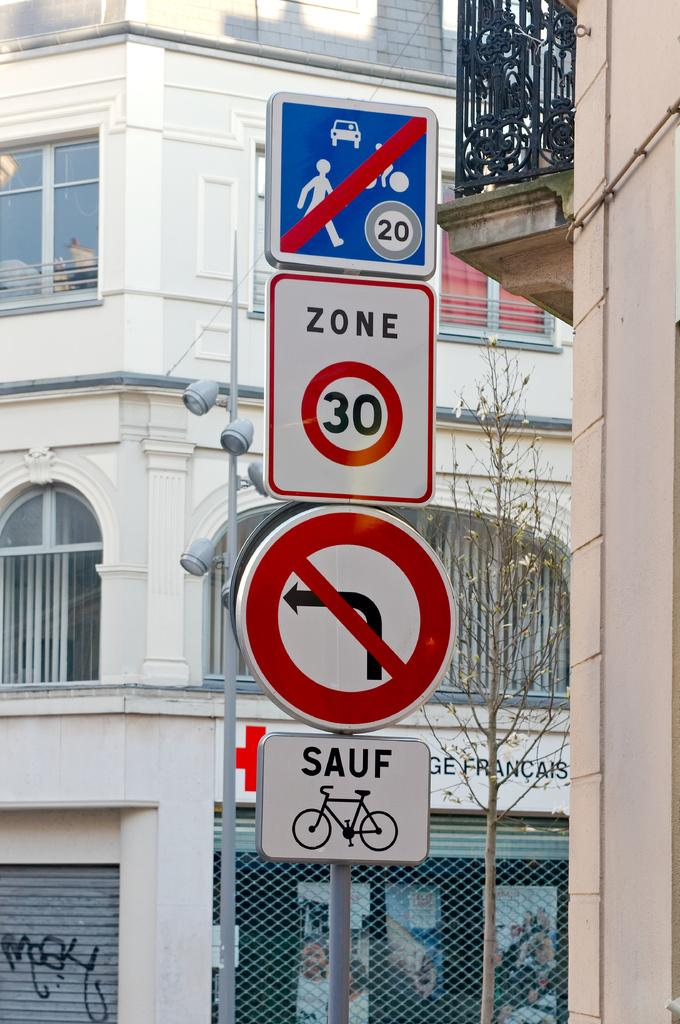<image>
Give a short and clear explanation of the subsequent image. Various signs are posted on a pole, including that it's a 30 zone. 